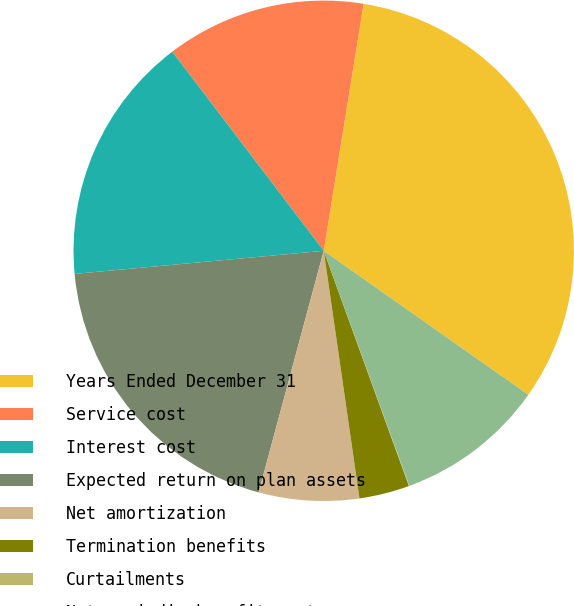Convert chart to OTSL. <chart><loc_0><loc_0><loc_500><loc_500><pie_chart><fcel>Years Ended December 31<fcel>Service cost<fcel>Interest cost<fcel>Expected return on plan assets<fcel>Net amortization<fcel>Termination benefits<fcel>Curtailments<fcel>Net periodic benefit cost<nl><fcel>32.21%<fcel>12.9%<fcel>16.12%<fcel>19.34%<fcel>6.47%<fcel>3.25%<fcel>0.03%<fcel>9.68%<nl></chart> 